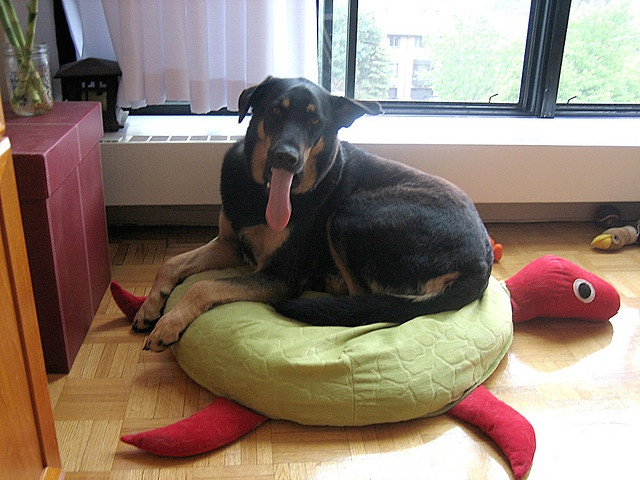Describe the objects in this image and their specific colors. I can see dog in olive, black, gray, and maroon tones and bed in olive, khaki, and maroon tones in this image. 